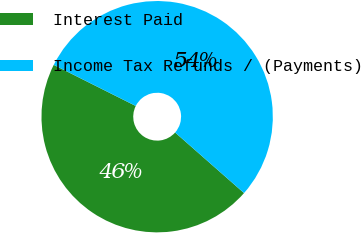Convert chart to OTSL. <chart><loc_0><loc_0><loc_500><loc_500><pie_chart><fcel>Interest Paid<fcel>Income Tax Refunds / (Payments)<nl><fcel>45.92%<fcel>54.08%<nl></chart> 